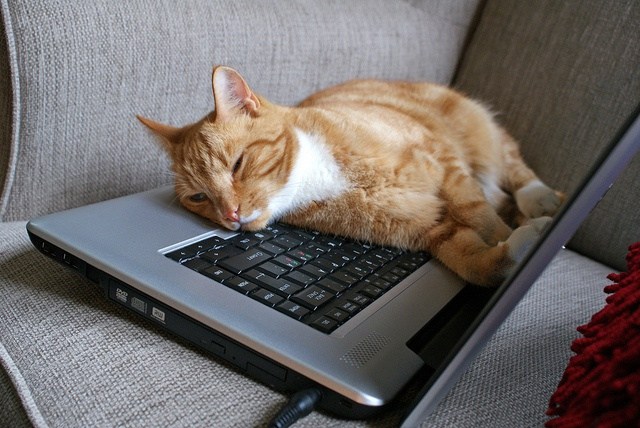Describe the objects in this image and their specific colors. I can see couch in gray, darkgray, and black tones, laptop in gray and black tones, and cat in gray, tan, and maroon tones in this image. 